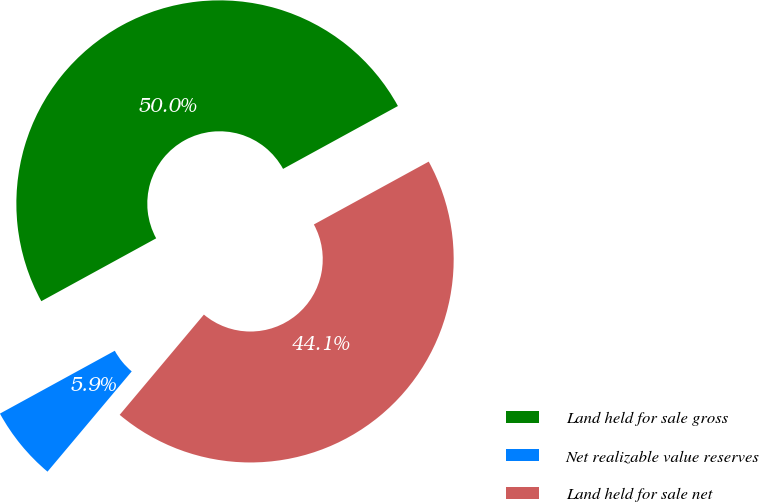Convert chart. <chart><loc_0><loc_0><loc_500><loc_500><pie_chart><fcel>Land held for sale gross<fcel>Net realizable value reserves<fcel>Land held for sale net<nl><fcel>50.0%<fcel>5.91%<fcel>44.09%<nl></chart> 